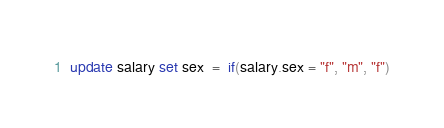Convert code to text. <code><loc_0><loc_0><loc_500><loc_500><_SQL_>update salary set sex  =  if(salary.sex = "f", "m", "f")</code> 